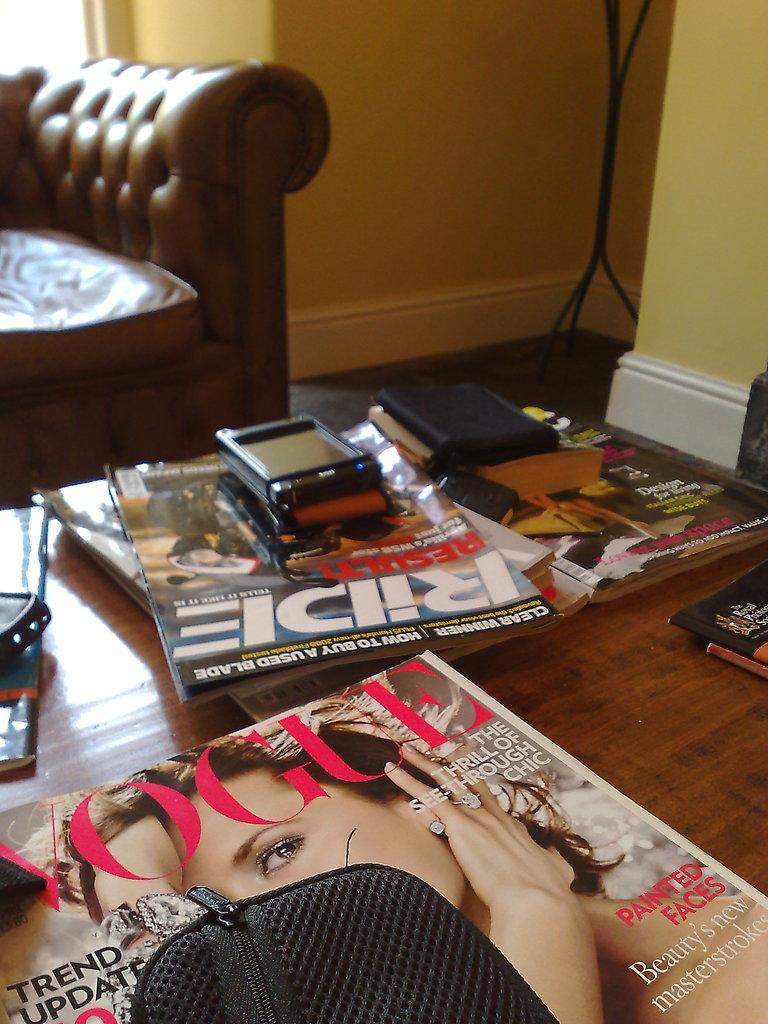What objects are on the table in the image? There are books, a purse, and a mobile on the table in the image. What type of furniture is in the image? There is a couch in the image. What is the color of the couch? The couch is brown in color. What is the color of the wall in the image? The wall is yellow in color. What type of wine is being served on the couch in the image? There is no wine present in the image; it only features books, a purse, a mobile, a couch, and a yellow wall. 